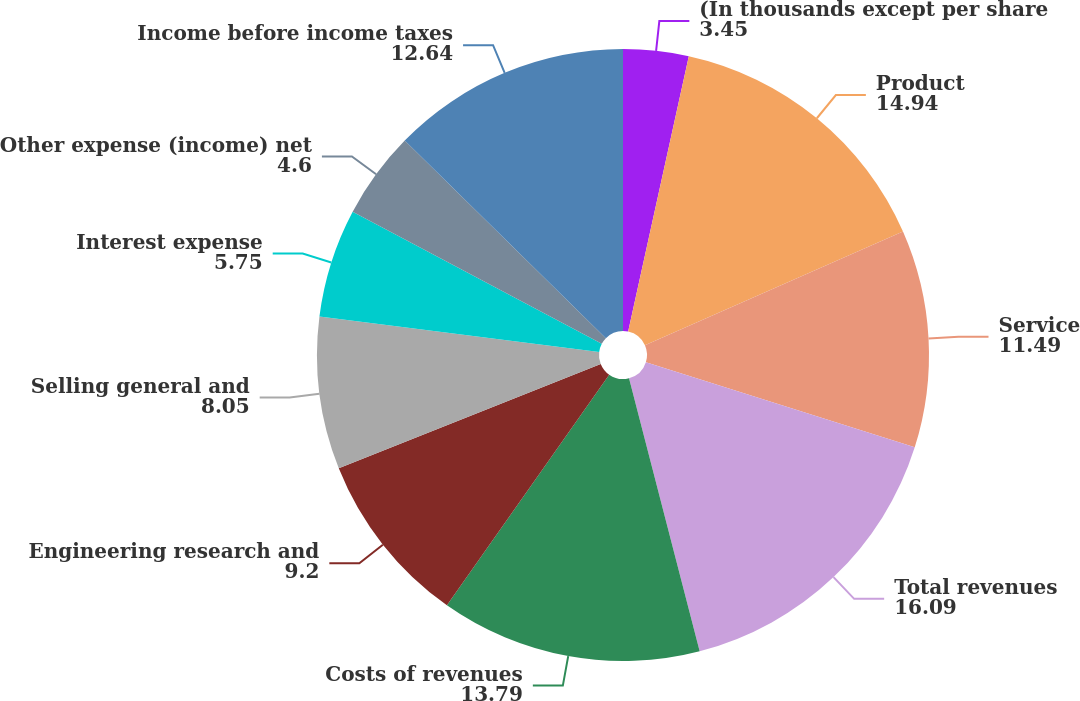Convert chart. <chart><loc_0><loc_0><loc_500><loc_500><pie_chart><fcel>(In thousands except per share<fcel>Product<fcel>Service<fcel>Total revenues<fcel>Costs of revenues<fcel>Engineering research and<fcel>Selling general and<fcel>Interest expense<fcel>Other expense (income) net<fcel>Income before income taxes<nl><fcel>3.45%<fcel>14.94%<fcel>11.49%<fcel>16.09%<fcel>13.79%<fcel>9.2%<fcel>8.05%<fcel>5.75%<fcel>4.6%<fcel>12.64%<nl></chart> 